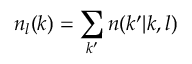Convert formula to latex. <formula><loc_0><loc_0><loc_500><loc_500>n _ { l } ( k ) = \sum _ { k ^ { \prime } } n ( k ^ { \prime } | k , l )</formula> 